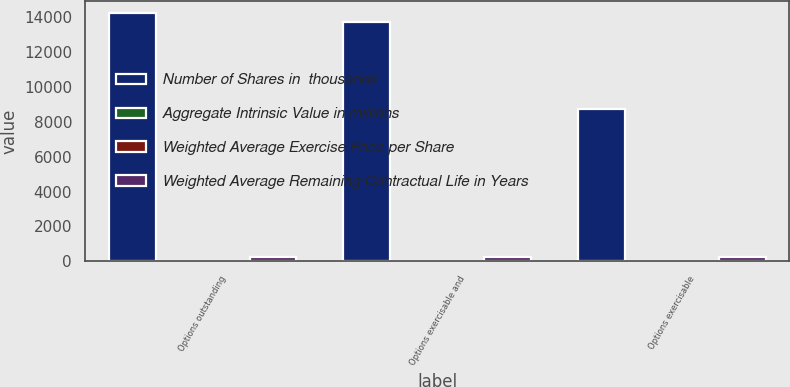Convert chart. <chart><loc_0><loc_0><loc_500><loc_500><stacked_bar_chart><ecel><fcel>Options outstanding<fcel>Options exercisable and<fcel>Options exercisable<nl><fcel>Number of Shares in  thousands<fcel>14206<fcel>13697<fcel>8731<nl><fcel>Aggregate Intrinsic Value in millions<fcel>4.93<fcel>4.81<fcel>3.29<nl><fcel>Weighted Average Exercise Price per Share<fcel>43.77<fcel>43.24<fcel>35.8<nl><fcel>Weighted Average Remaining Contractual Life in Years<fcel>276<fcel>273<fcel>239<nl></chart> 